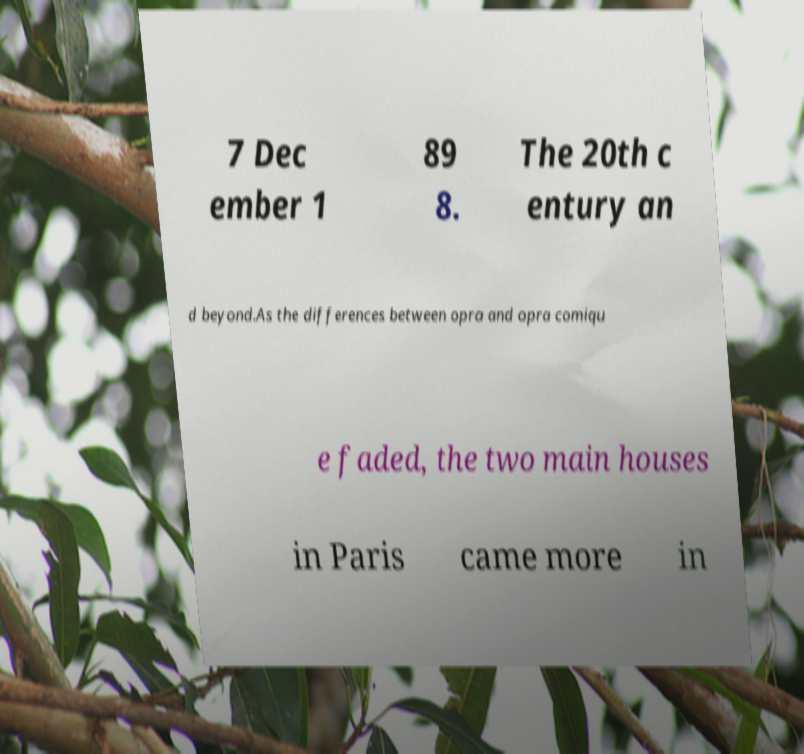Could you assist in decoding the text presented in this image and type it out clearly? 7 Dec ember 1 89 8. The 20th c entury an d beyond.As the differences between opra and opra comiqu e faded, the two main houses in Paris came more in 